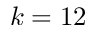Convert formula to latex. <formula><loc_0><loc_0><loc_500><loc_500>k = 1 2</formula> 